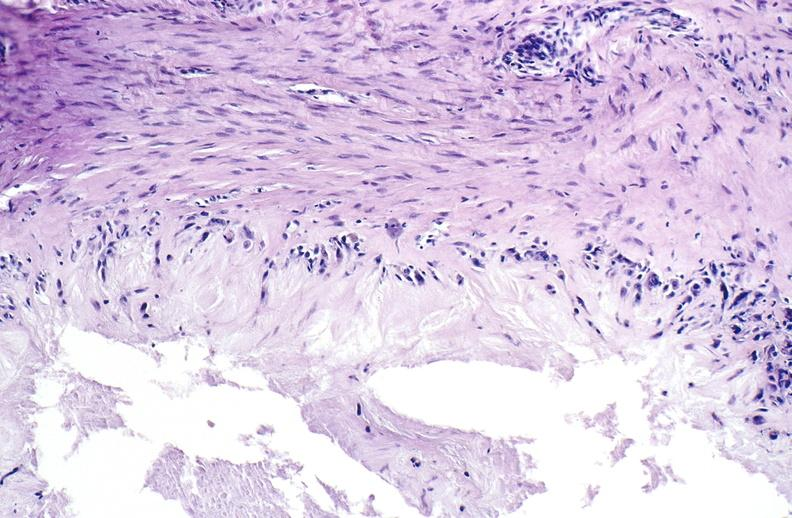does this image show gout?
Answer the question using a single word or phrase. Yes 